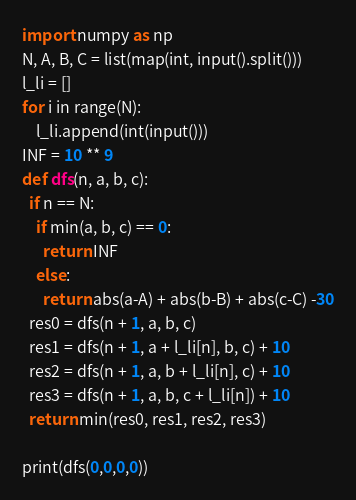<code> <loc_0><loc_0><loc_500><loc_500><_Python_>import numpy as np
N, A, B, C = list(map(int, input().split()))
l_li = []
for i in range(N):
    l_li.append(int(input()))
INF = 10 ** 9
def dfs(n, a, b, c):
  if n == N:
    if min(a, b, c) == 0:
      return INF
    else:
      return abs(a-A) + abs(b-B) + abs(c-C) -30
  res0 = dfs(n + 1, a, b, c)
  res1 = dfs(n + 1, a + l_li[n], b, c) + 10
  res2 = dfs(n + 1, a, b + l_li[n], c) + 10
  res3 = dfs(n + 1, a, b, c + l_li[n]) + 10
  return min(res0, res1, res2, res3)

print(dfs(0,0,0,0))</code> 